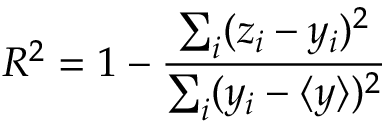Convert formula to latex. <formula><loc_0><loc_0><loc_500><loc_500>R ^ { 2 } = 1 - \frac { \sum _ { i } ( z _ { i } - y _ { i } ) ^ { 2 } } { \sum _ { i } ( y _ { i } - \langle y \rangle ) ^ { 2 } }</formula> 